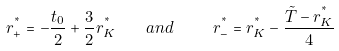<formula> <loc_0><loc_0><loc_500><loc_500>r ^ { ^ { * } } _ { + } = - \frac { t _ { 0 } } { 2 } + \frac { 3 } { 2 } r ^ { ^ { * } } _ { K } \quad a n d \ \quad r ^ { ^ { * } } _ { - } = r ^ { ^ { * } } _ { K } - \frac { \tilde { T } - r ^ { ^ { * } } _ { K } } { 4 }</formula> 